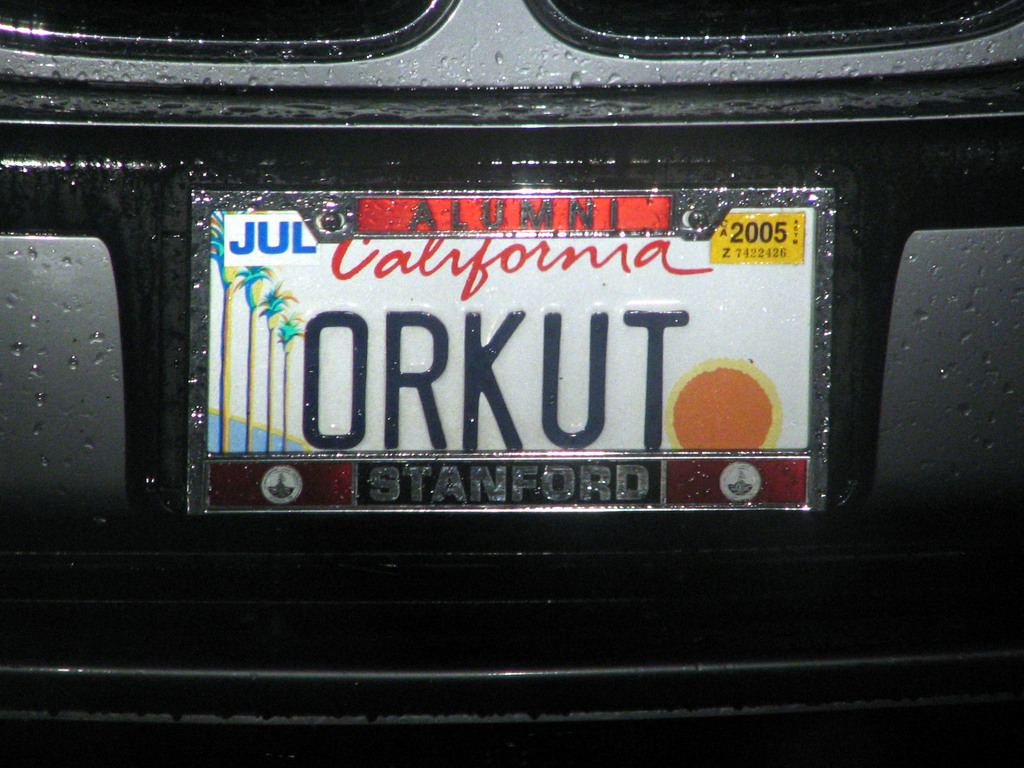Can you explain the significance of the design on the license plate? Certainly! The license plate features a distinctive design emblematic of California - with a sunset and palm trees, both symbols widely recognized as part of the state's identity. The red sun setting over a tranquil sea, flanked by palm trees, evokes a sense of the typical Californian landscape, famous for its beaches and picturesque sunsets. This kind of imagery is commonly used to promote and celebrate the state's natural beauty and laid-back lifestyle. 